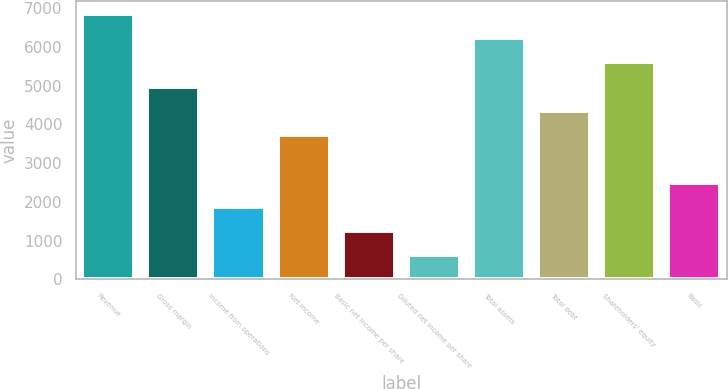Convert chart. <chart><loc_0><loc_0><loc_500><loc_500><bar_chart><fcel>Revenue<fcel>Gross margin<fcel>Income from operations<fcel>Net income<fcel>Basic net income per share<fcel>Diluted net income per share<fcel>Total assets<fcel>Total debt<fcel>Shareholders' equity<fcel>Basic<nl><fcel>6846.38<fcel>4979.24<fcel>1867.34<fcel>3734.48<fcel>1244.96<fcel>622.58<fcel>6224<fcel>4356.86<fcel>5601.62<fcel>2489.72<nl></chart> 